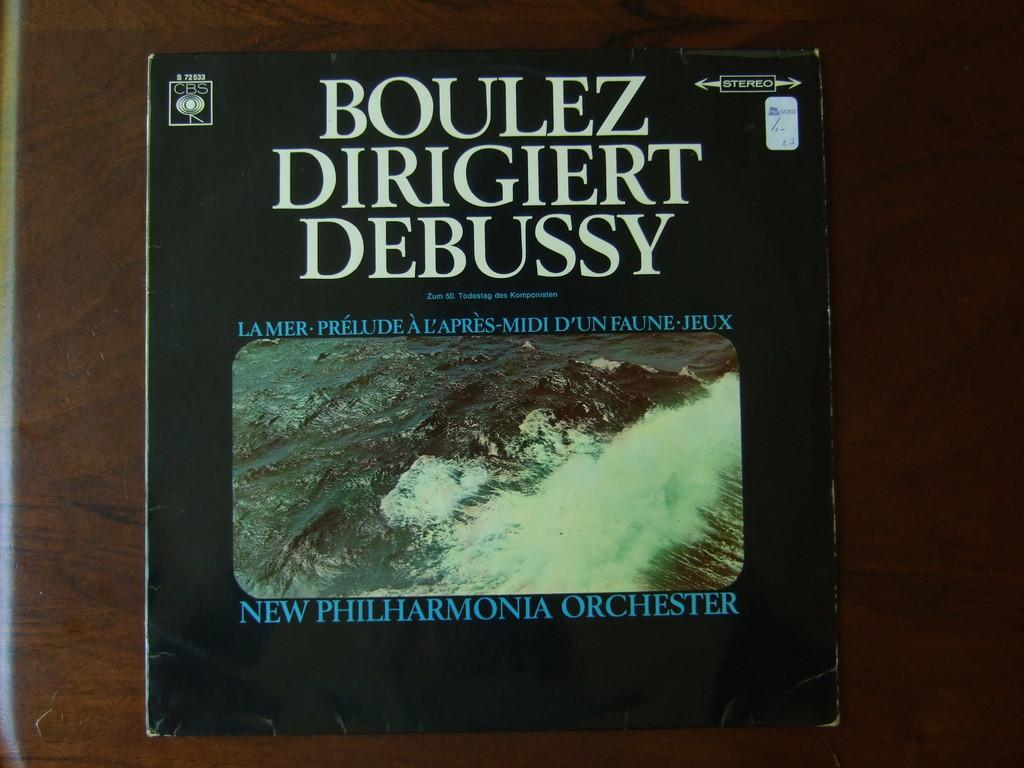<image>
Summarize the visual content of the image. An old record sleeve tells us the LP is of an orchestra playing Debussy classical music. 